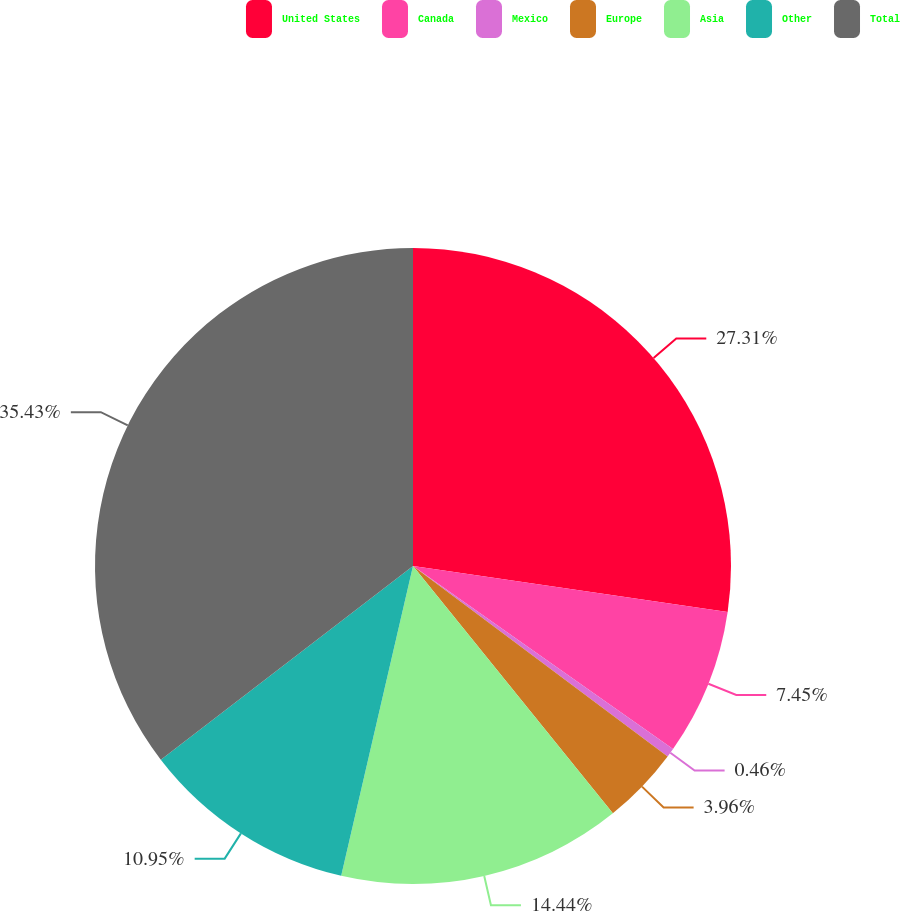<chart> <loc_0><loc_0><loc_500><loc_500><pie_chart><fcel>United States<fcel>Canada<fcel>Mexico<fcel>Europe<fcel>Asia<fcel>Other<fcel>Total<nl><fcel>27.31%<fcel>7.45%<fcel>0.46%<fcel>3.96%<fcel>14.44%<fcel>10.95%<fcel>35.42%<nl></chart> 